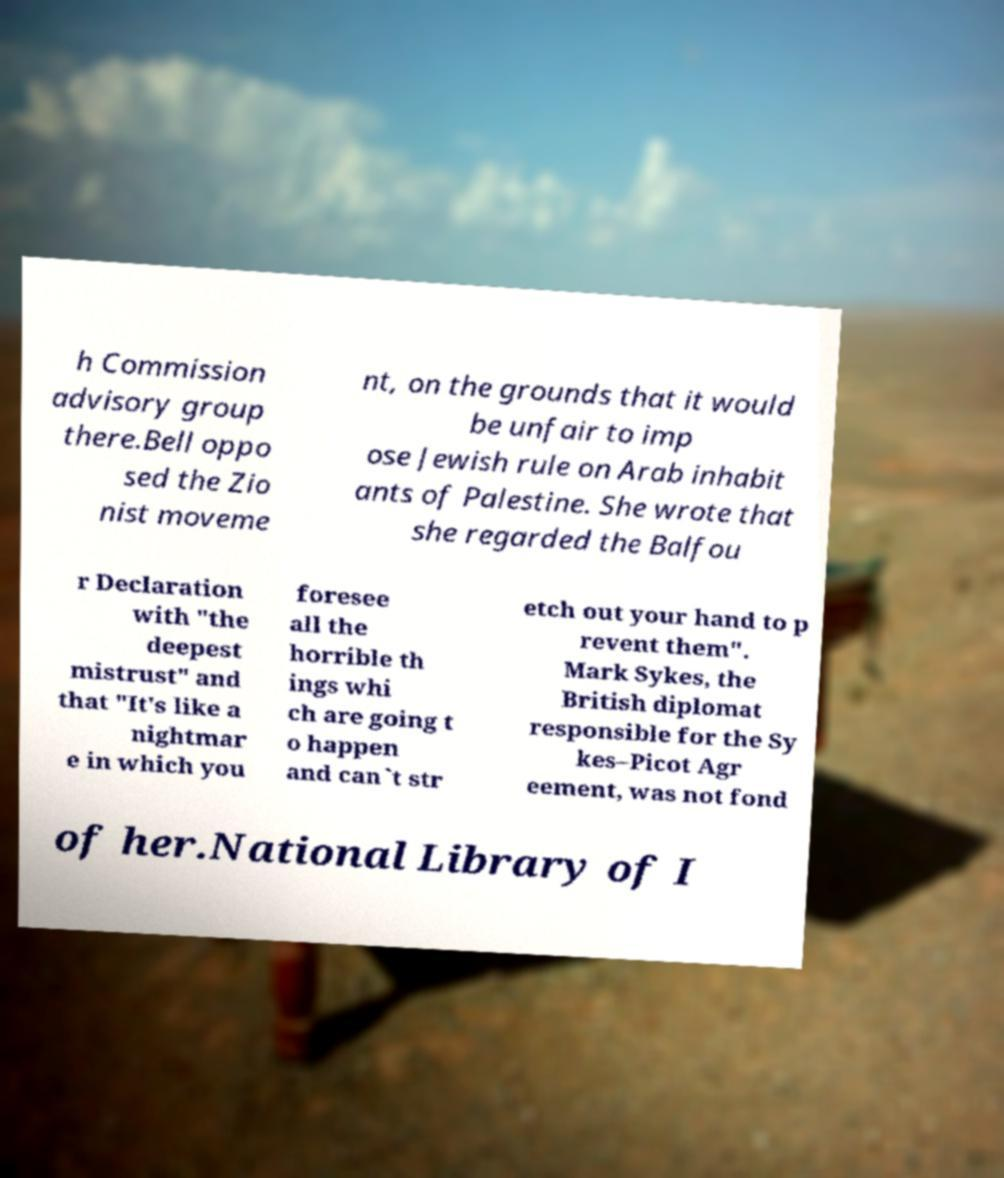Could you assist in decoding the text presented in this image and type it out clearly? h Commission advisory group there.Bell oppo sed the Zio nist moveme nt, on the grounds that it would be unfair to imp ose Jewish rule on Arab inhabit ants of Palestine. She wrote that she regarded the Balfou r Declaration with "the deepest mistrust" and that "It's like a nightmar e in which you foresee all the horrible th ings whi ch are going t o happen and can`t str etch out your hand to p revent them". Mark Sykes, the British diplomat responsible for the Sy kes–Picot Agr eement, was not fond of her.National Library of I 